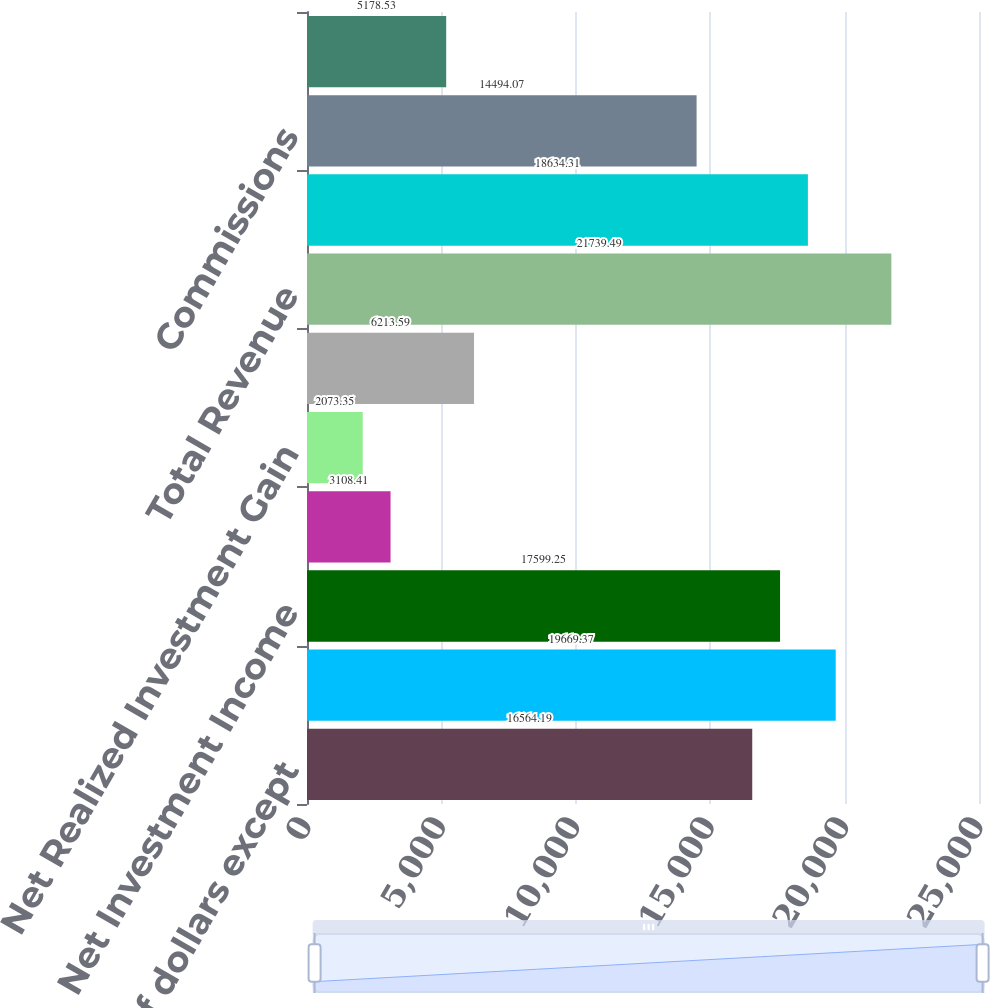Convert chart. <chart><loc_0><loc_0><loc_500><loc_500><bar_chart><fcel>(in millions of dollars except<fcel>Premium Income<fcel>Net Investment Income<fcel>Other Net Realized Investment<fcel>Net Realized Investment Gain<fcel>Other Income<fcel>Total Revenue<fcel>Benefits and Change in<fcel>Commissions<fcel>Interest and Debt Expense<nl><fcel>16564.2<fcel>19669.4<fcel>17599.2<fcel>3108.41<fcel>2073.35<fcel>6213.59<fcel>21739.5<fcel>18634.3<fcel>14494.1<fcel>5178.53<nl></chart> 